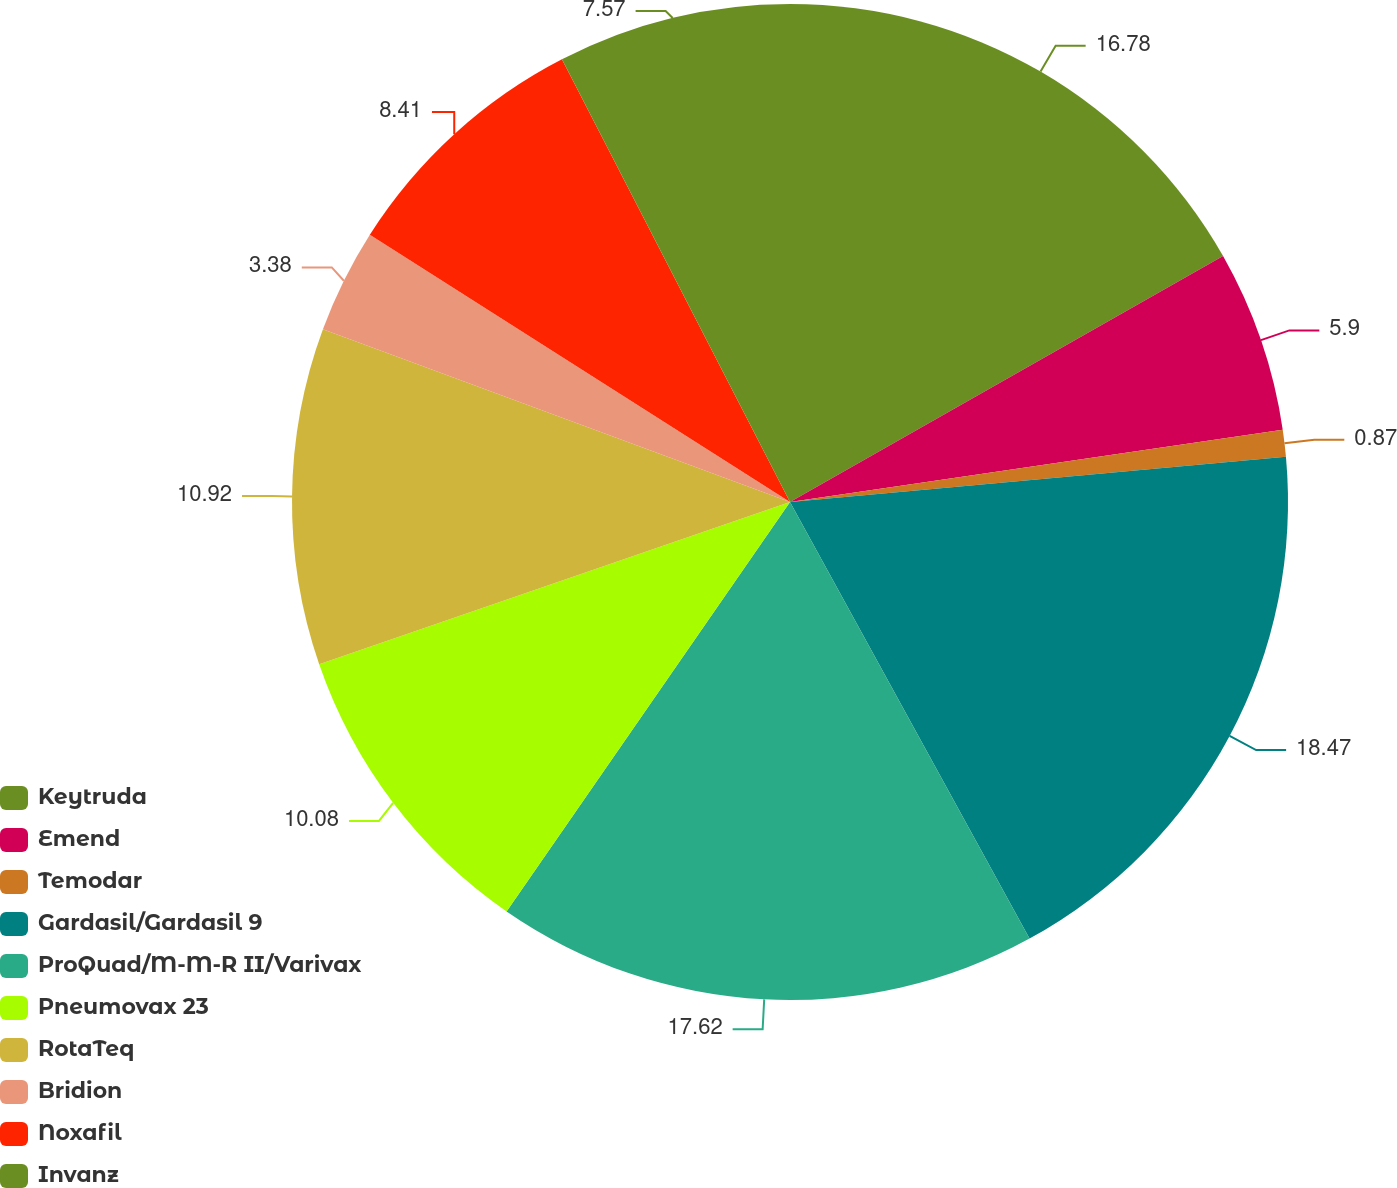Convert chart. <chart><loc_0><loc_0><loc_500><loc_500><pie_chart><fcel>Keytruda<fcel>Emend<fcel>Temodar<fcel>Gardasil/Gardasil 9<fcel>ProQuad/M-M-R II/Varivax<fcel>Pneumovax 23<fcel>RotaTeq<fcel>Bridion<fcel>Noxafil<fcel>Invanz<nl><fcel>16.78%<fcel>5.9%<fcel>0.87%<fcel>18.46%<fcel>17.62%<fcel>10.08%<fcel>10.92%<fcel>3.38%<fcel>8.41%<fcel>7.57%<nl></chart> 